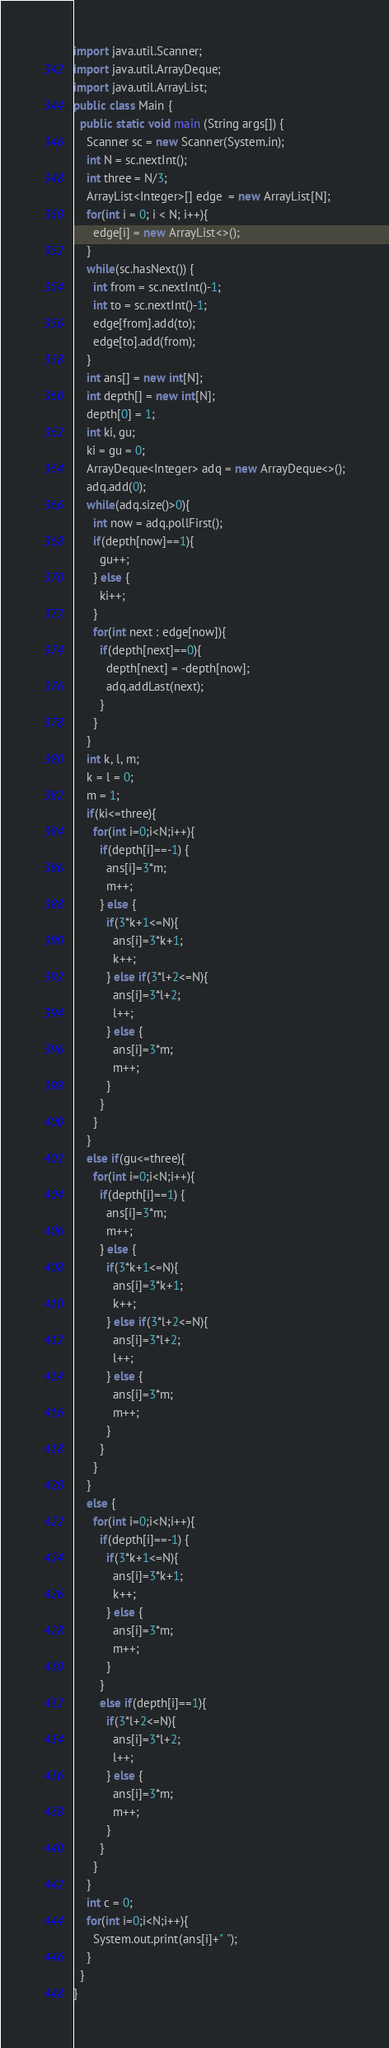<code> <loc_0><loc_0><loc_500><loc_500><_Java_>import java.util.Scanner;
import java.util.ArrayDeque;
import java.util.ArrayList;
public class Main {
  public static void main (String args[]) {
    Scanner sc = new Scanner(System.in);
    int N = sc.nextInt();
    int three = N/3;
    ArrayList<Integer>[] edge  = new ArrayList[N];
    for(int i = 0; i < N; i++){
      edge[i] = new ArrayList<>();
    }
    while(sc.hasNext()) {
      int from = sc.nextInt()-1;
      int to = sc.nextInt()-1;
      edge[from].add(to);
      edge[to].add(from);
    }
    int ans[] = new int[N];
    int depth[] = new int[N];
    depth[0] = 1;
    int ki, gu;
    ki = gu = 0;
    ArrayDeque<Integer> adq = new ArrayDeque<>();
    adq.add(0);
    while(adq.size()>0){
      int now = adq.pollFirst();
      if(depth[now]==1){
        gu++;
      } else {
        ki++;
      }
      for(int next : edge[now]){
        if(depth[next]==0){
          depth[next] = -depth[now];
          adq.addLast(next);
        }
      }
    }
    int k, l, m;
    k = l = 0;
    m = 1;
    if(ki<=three){
      for(int i=0;i<N;i++){
        if(depth[i]==-1) {
          ans[i]=3*m;
          m++;
        } else {
          if(3*k+1<=N){
            ans[i]=3*k+1;
            k++;
          } else if(3*l+2<=N){
            ans[i]=3*l+2;
            l++;
          } else {
            ans[i]=3*m;
            m++;
          }
        }
      }
    }
    else if(gu<=three){
      for(int i=0;i<N;i++){
        if(depth[i]==1) {
          ans[i]=3*m;
          m++;
        } else {
          if(3*k+1<=N){
            ans[i]=3*k+1;
            k++;
          } else if(3*l+2<=N){
            ans[i]=3*l+2;
            l++;
          } else {
            ans[i]=3*m;
            m++;
          }
        }
      }
    }
    else {
      for(int i=0;i<N;i++){
        if(depth[i]==-1) {
          if(3*k+1<=N){
            ans[i]=3*k+1;
            k++;
          } else {
            ans[i]=3*m;
            m++;
          }
        }
        else if(depth[i]==1){
          if(3*l+2<=N){
            ans[i]=3*l+2;
            l++;
          } else {
            ans[i]=3*m;
            m++;
          }
        }
      }
    }
    int c = 0;
    for(int i=0;i<N;i++){
      System.out.print(ans[i]+" ");
    }
  }
}</code> 